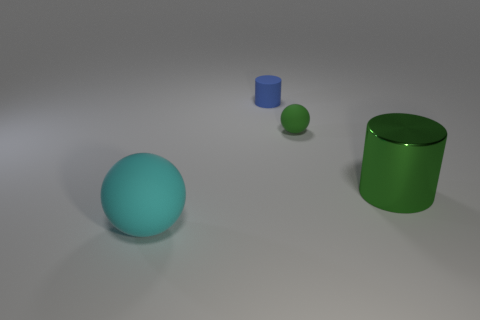There is a small blue object that is the same material as the cyan sphere; what shape is it?
Give a very brief answer. Cylinder. How many large objects are both behind the big cyan sphere and to the left of the tiny blue cylinder?
Your response must be concise. 0. What is the size of the sphere behind the big cyan sphere?
Your answer should be very brief. Small. How many other objects are the same color as the metallic cylinder?
Provide a short and direct response. 1. There is a big thing to the right of the matte thing in front of the green matte object; what is it made of?
Ensure brevity in your answer.  Metal. Is the color of the tiny object that is to the right of the tiny cylinder the same as the metal cylinder?
Offer a very short reply. Yes. Is there anything else that is the same material as the cyan ball?
Provide a succinct answer. Yes. How many other big metal things are the same shape as the blue object?
Keep it short and to the point. 1. What size is the green sphere that is the same material as the small cylinder?
Offer a terse response. Small. Are there any green shiny objects behind the sphere to the right of the matte ball in front of the green metallic cylinder?
Provide a succinct answer. No. 